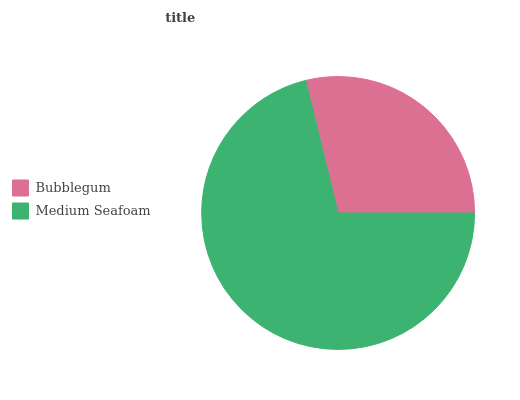Is Bubblegum the minimum?
Answer yes or no. Yes. Is Medium Seafoam the maximum?
Answer yes or no. Yes. Is Medium Seafoam the minimum?
Answer yes or no. No. Is Medium Seafoam greater than Bubblegum?
Answer yes or no. Yes. Is Bubblegum less than Medium Seafoam?
Answer yes or no. Yes. Is Bubblegum greater than Medium Seafoam?
Answer yes or no. No. Is Medium Seafoam less than Bubblegum?
Answer yes or no. No. Is Medium Seafoam the high median?
Answer yes or no. Yes. Is Bubblegum the low median?
Answer yes or no. Yes. Is Bubblegum the high median?
Answer yes or no. No. Is Medium Seafoam the low median?
Answer yes or no. No. 